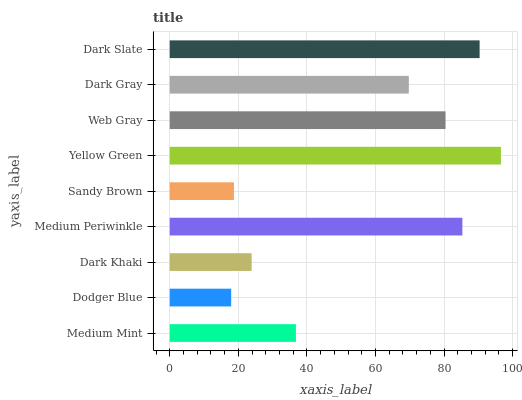Is Dodger Blue the minimum?
Answer yes or no. Yes. Is Yellow Green the maximum?
Answer yes or no. Yes. Is Dark Khaki the minimum?
Answer yes or no. No. Is Dark Khaki the maximum?
Answer yes or no. No. Is Dark Khaki greater than Dodger Blue?
Answer yes or no. Yes. Is Dodger Blue less than Dark Khaki?
Answer yes or no. Yes. Is Dodger Blue greater than Dark Khaki?
Answer yes or no. No. Is Dark Khaki less than Dodger Blue?
Answer yes or no. No. Is Dark Gray the high median?
Answer yes or no. Yes. Is Dark Gray the low median?
Answer yes or no. Yes. Is Sandy Brown the high median?
Answer yes or no. No. Is Dark Khaki the low median?
Answer yes or no. No. 